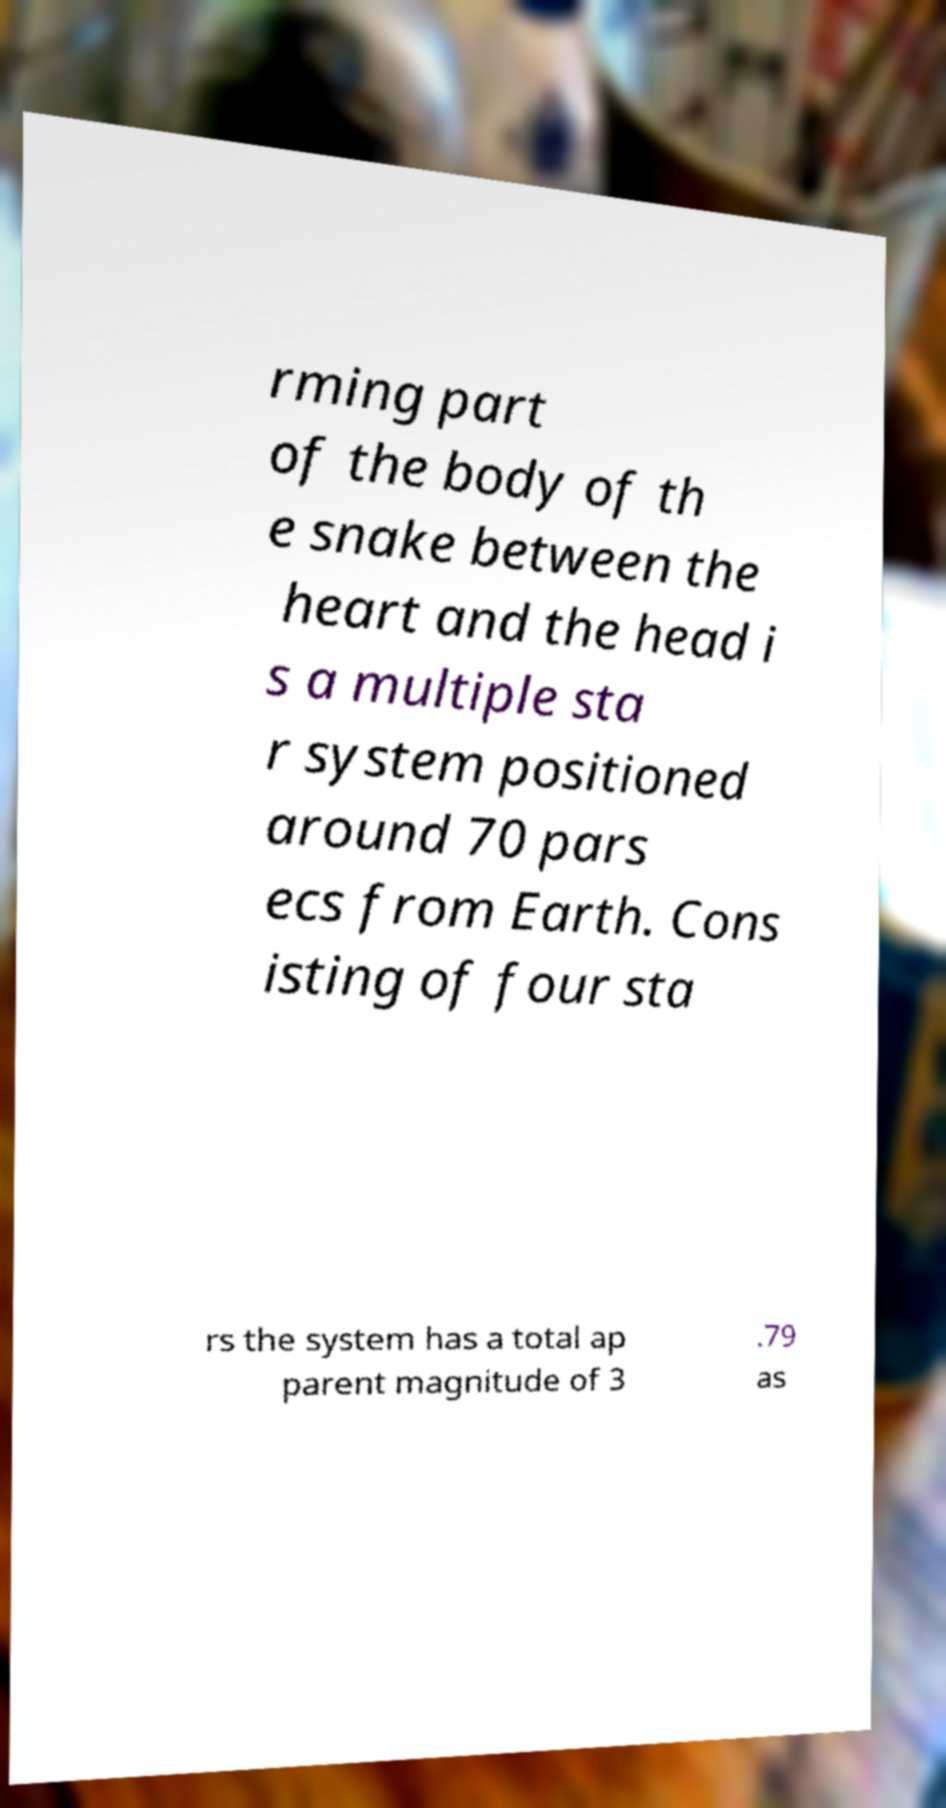I need the written content from this picture converted into text. Can you do that? rming part of the body of th e snake between the heart and the head i s a multiple sta r system positioned around 70 pars ecs from Earth. Cons isting of four sta rs the system has a total ap parent magnitude of 3 .79 as 